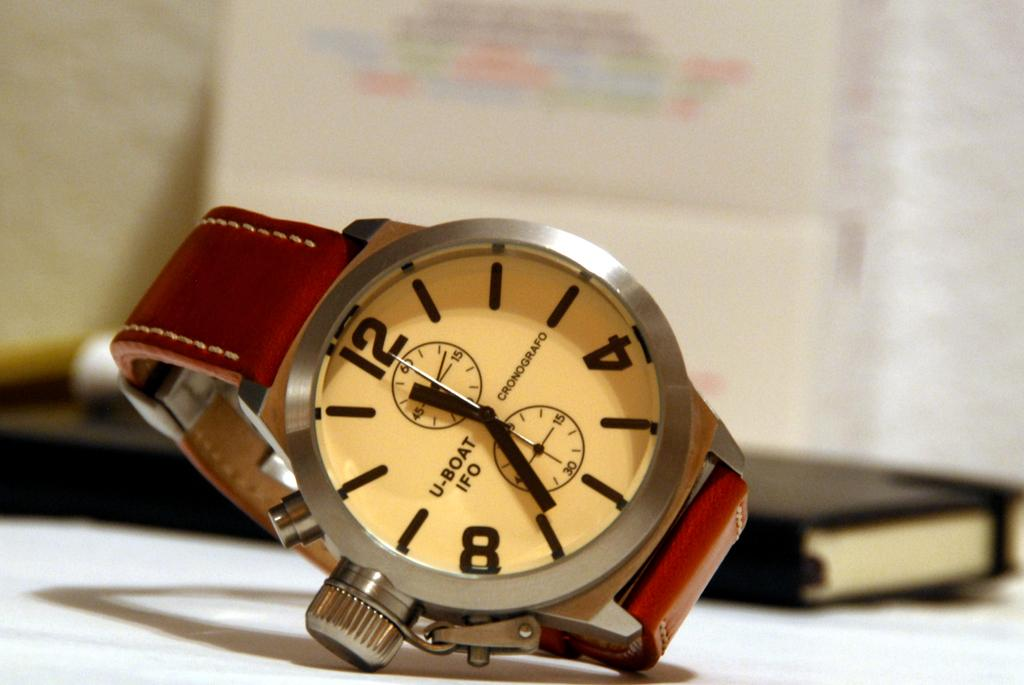<image>
Present a compact description of the photo's key features. a wrist watch with U Boat IFO on it sits on a table 